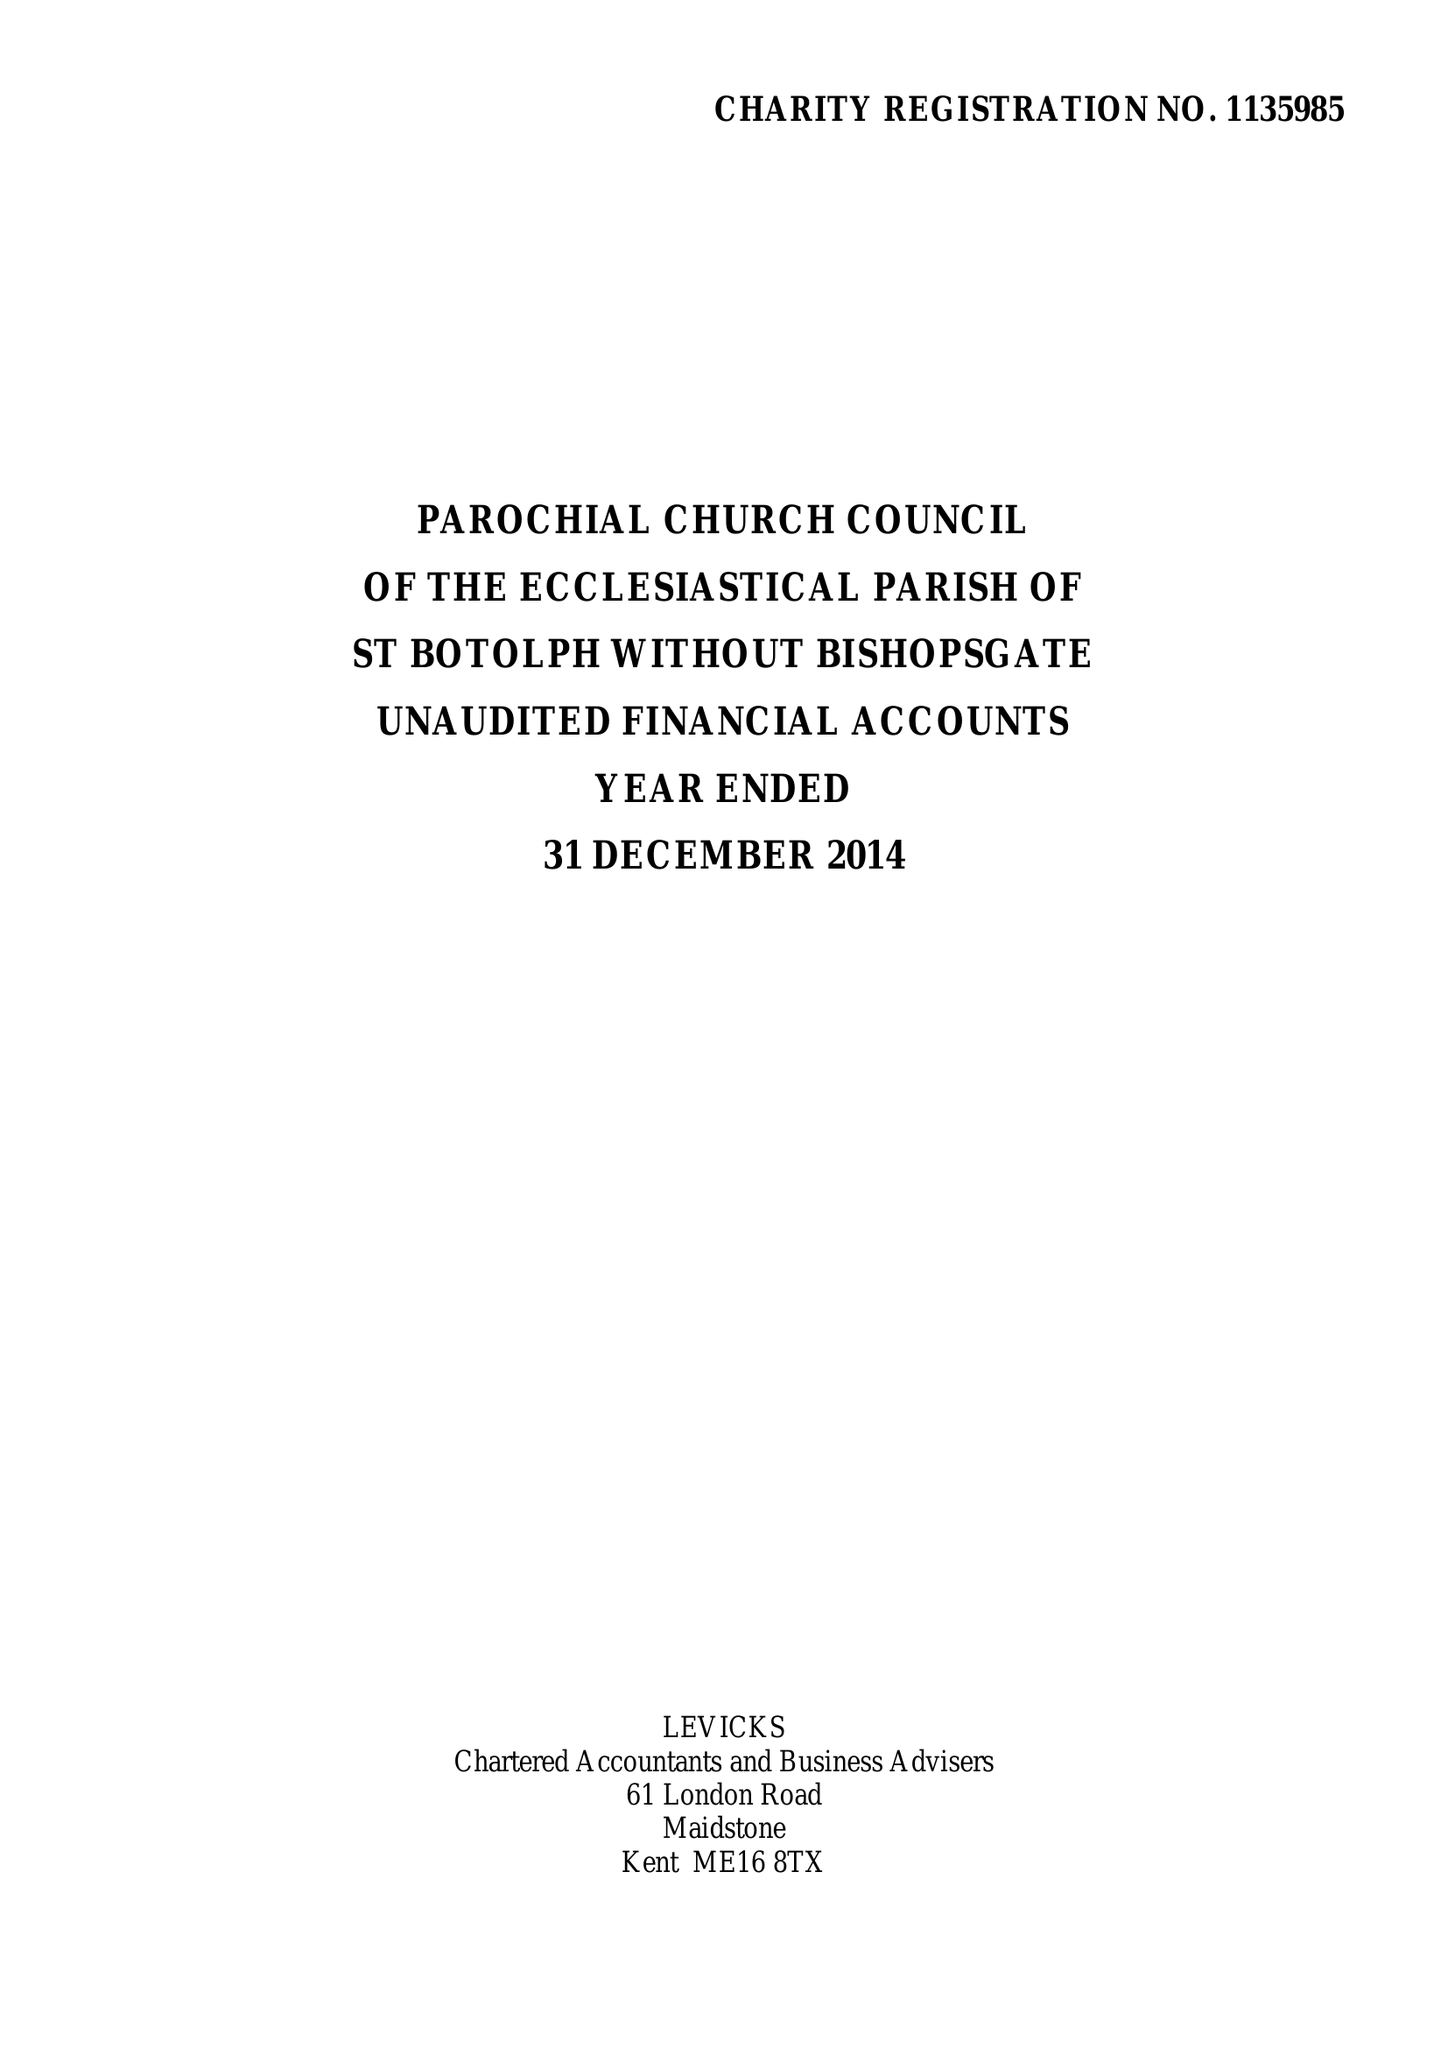What is the value for the spending_annually_in_british_pounds?
Answer the question using a single word or phrase. 285009.00 